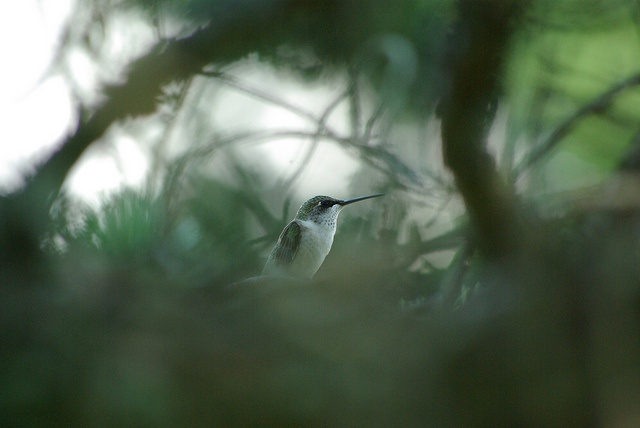Describe the objects in this image and their specific colors. I can see a bird in white, teal, darkgray, black, and darkgreen tones in this image. 